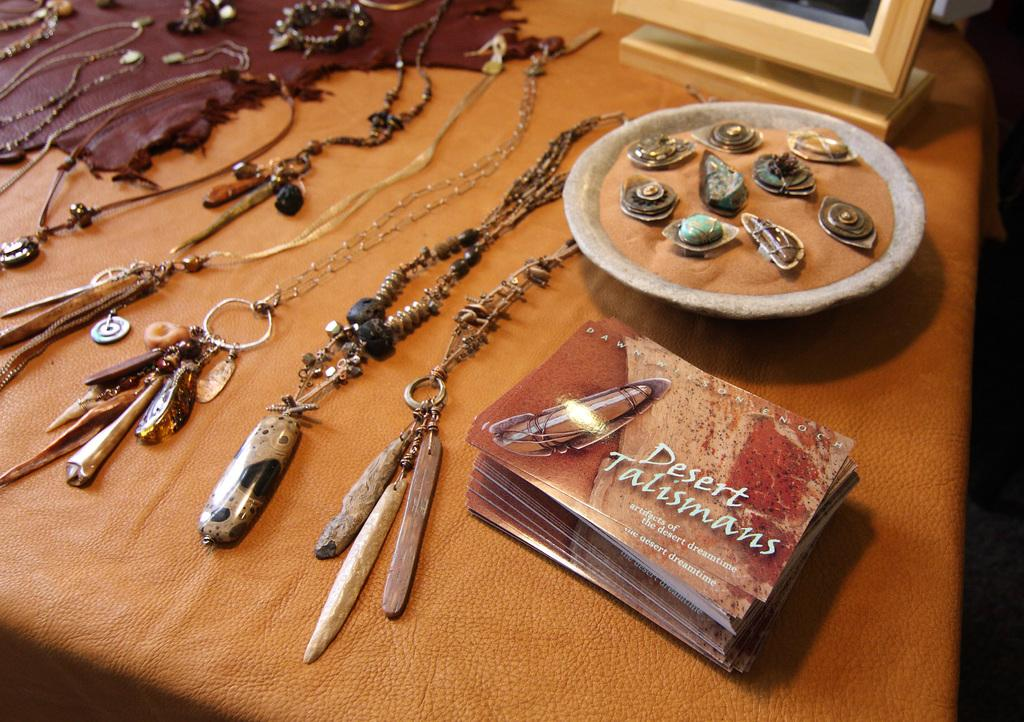<image>
Summarize the visual content of the image. The Desert Talisman sits on a table next to several pieces of jewelry. 